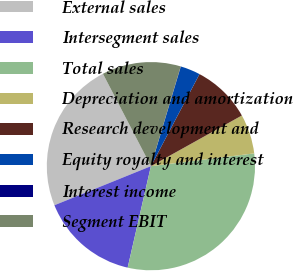Convert chart to OTSL. <chart><loc_0><loc_0><loc_500><loc_500><pie_chart><fcel>External sales<fcel>Intersegment sales<fcel>Total sales<fcel>Depreciation and amortization<fcel>Research development and<fcel>Equity royalty and interest<fcel>Interest income<fcel>Segment EBIT<nl><fcel>23.5%<fcel>15.29%<fcel>30.54%<fcel>6.13%<fcel>9.18%<fcel>3.08%<fcel>0.03%<fcel>12.24%<nl></chart> 